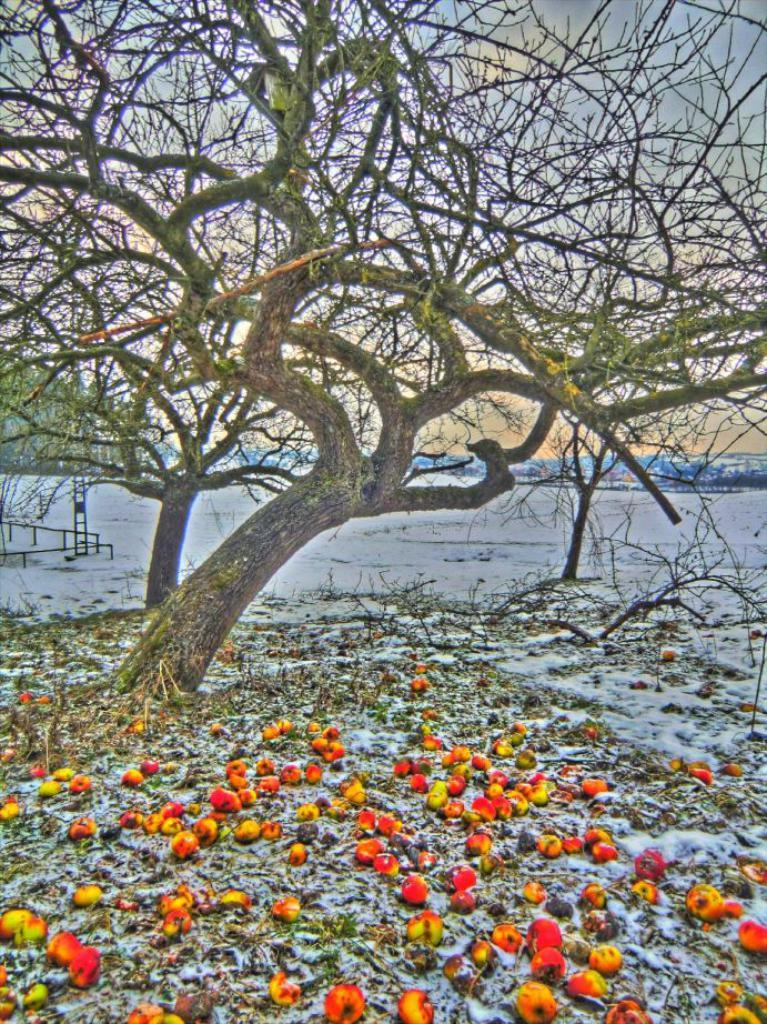What is the main subject in the center of the image? There is a tree in the center of the image. What objects can be seen in the image besides the tree? There are rods and a pole in the image. What is located at the bottom of the image? There are apples at the bottom of the image. What is the weather condition in the image? There is snow in the image, indicating a cold or wintery setting. What does the caption say about the father in the image? There is no caption or mention of a father in the image; it only features a tree, rods, a pole, apples, and snow. 